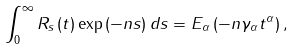<formula> <loc_0><loc_0><loc_500><loc_500>\int _ { 0 } ^ { \infty } R _ { s } \left ( t \right ) \exp \left ( - n s \right ) d s = E _ { \alpha } \left ( - n \gamma _ { \alpha } t ^ { \alpha } \right ) ,</formula> 